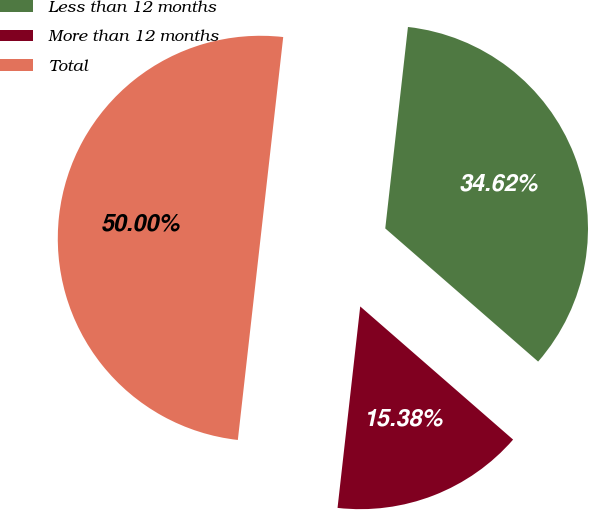<chart> <loc_0><loc_0><loc_500><loc_500><pie_chart><fcel>Less than 12 months<fcel>More than 12 months<fcel>Total<nl><fcel>34.62%<fcel>15.38%<fcel>50.0%<nl></chart> 